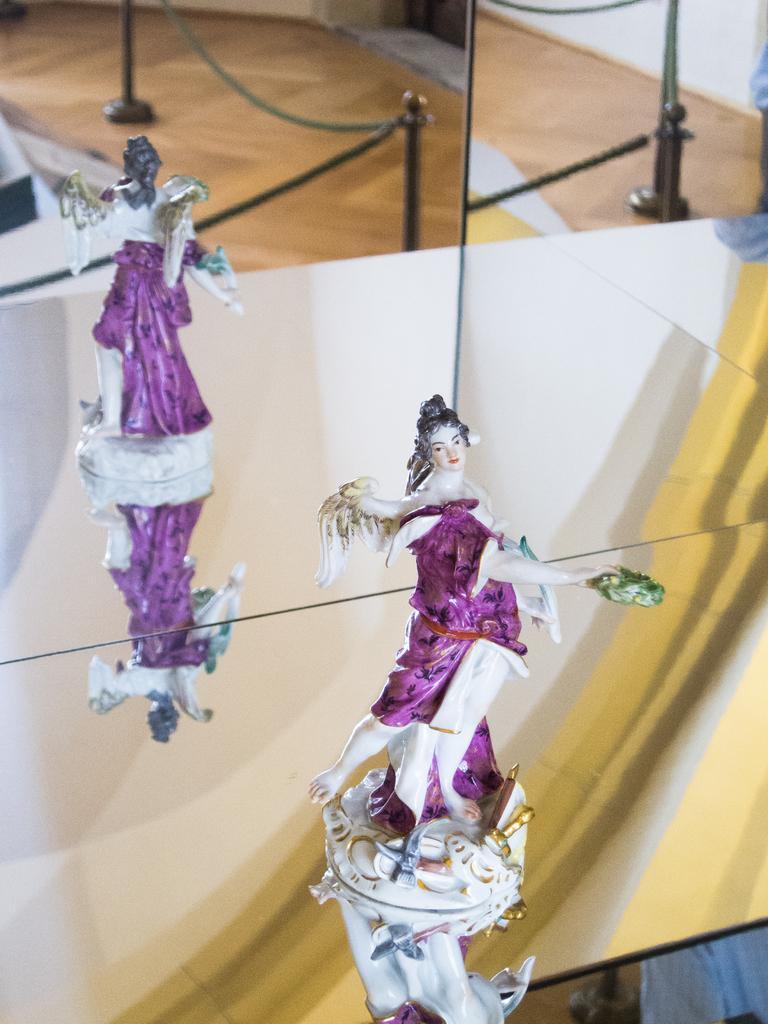How would you summarize this image in a sentence or two? In this image, I can see a small sculpture of the woman standing. This is the mirror. I can see the reflection of the sculpture and an iron chain with poles. 